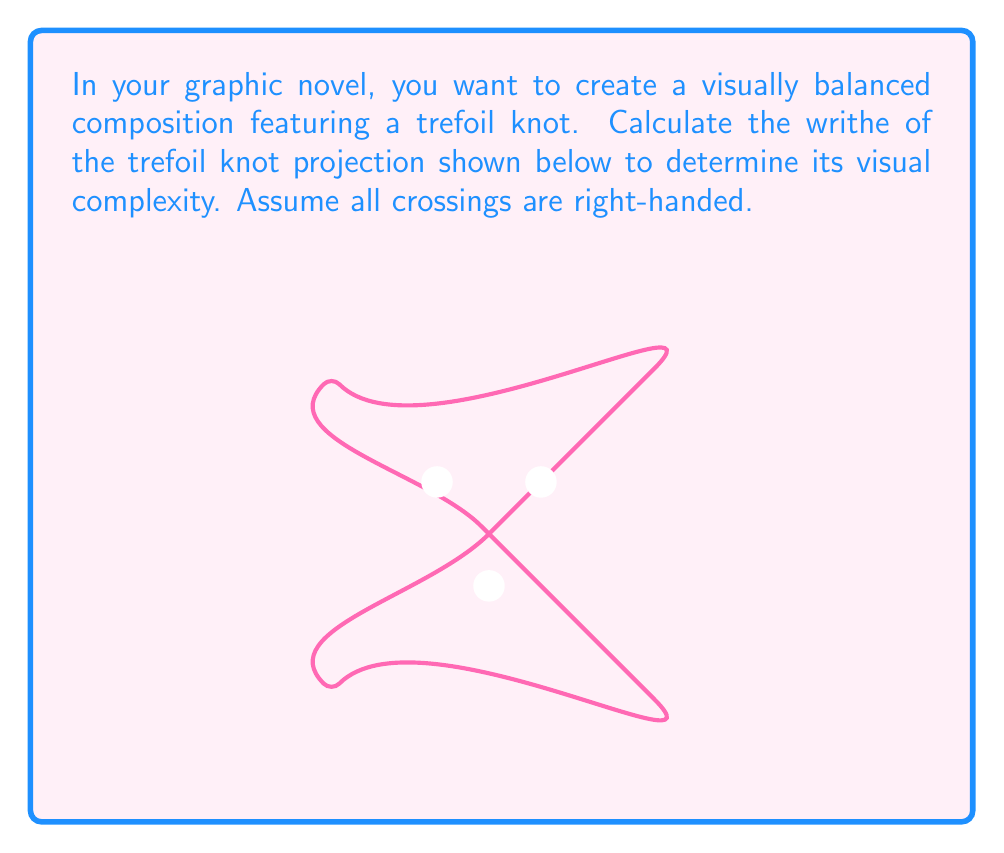Can you solve this math problem? To calculate the writhe of a knot projection, we need to follow these steps:

1) Identify all crossings in the knot projection.
2) Assign a value to each crossing:
   - +1 for right-handed crossings
   - -1 for left-handed crossings
3) Sum up all these values.

For the trefoil knot projection shown:

1) We can see that there are 3 crossings.

2) We're told that all crossings are right-handed, so each crossing is assigned a value of +1.

3) Now, we sum up these values:

   $$\text{Writhe} = (+1) + (+1) + (+1) = +3$$

Therefore, the writhe of this trefoil knot projection is +3.

In terms of visual complexity for your graphic novel panel, a higher absolute value of writhe generally indicates a more complex-looking knot. A writhe of +3 suggests a moderately complex visual element that could add interesting detail to your composition without overwhelming it.
Answer: $+3$ 